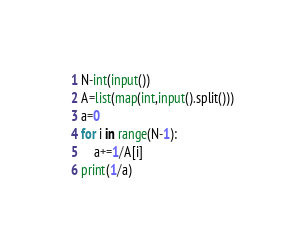<code> <loc_0><loc_0><loc_500><loc_500><_Python_>N-int(input())
A=list(map(int,input().split()))
a=0
for i in range(N-1):
    a+=1/A[i]
print(1/a)</code> 